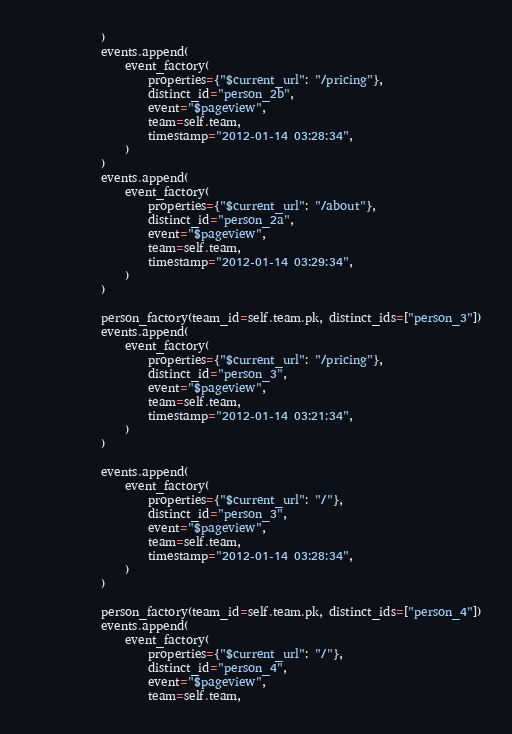<code> <loc_0><loc_0><loc_500><loc_500><_Python_>            )
            events.append(
                event_factory(
                    properties={"$current_url": "/pricing"},
                    distinct_id="person_2b",
                    event="$pageview",
                    team=self.team,
                    timestamp="2012-01-14 03:28:34",
                )
            )
            events.append(
                event_factory(
                    properties={"$current_url": "/about"},
                    distinct_id="person_2a",
                    event="$pageview",
                    team=self.team,
                    timestamp="2012-01-14 03:29:34",
                )
            )

            person_factory(team_id=self.team.pk, distinct_ids=["person_3"])
            events.append(
                event_factory(
                    properties={"$current_url": "/pricing"},
                    distinct_id="person_3",
                    event="$pageview",
                    team=self.team,
                    timestamp="2012-01-14 03:21:34",
                )
            )

            events.append(
                event_factory(
                    properties={"$current_url": "/"},
                    distinct_id="person_3",
                    event="$pageview",
                    team=self.team,
                    timestamp="2012-01-14 03:28:34",
                )
            )

            person_factory(team_id=self.team.pk, distinct_ids=["person_4"])
            events.append(
                event_factory(
                    properties={"$current_url": "/"},
                    distinct_id="person_4",
                    event="$pageview",
                    team=self.team,</code> 